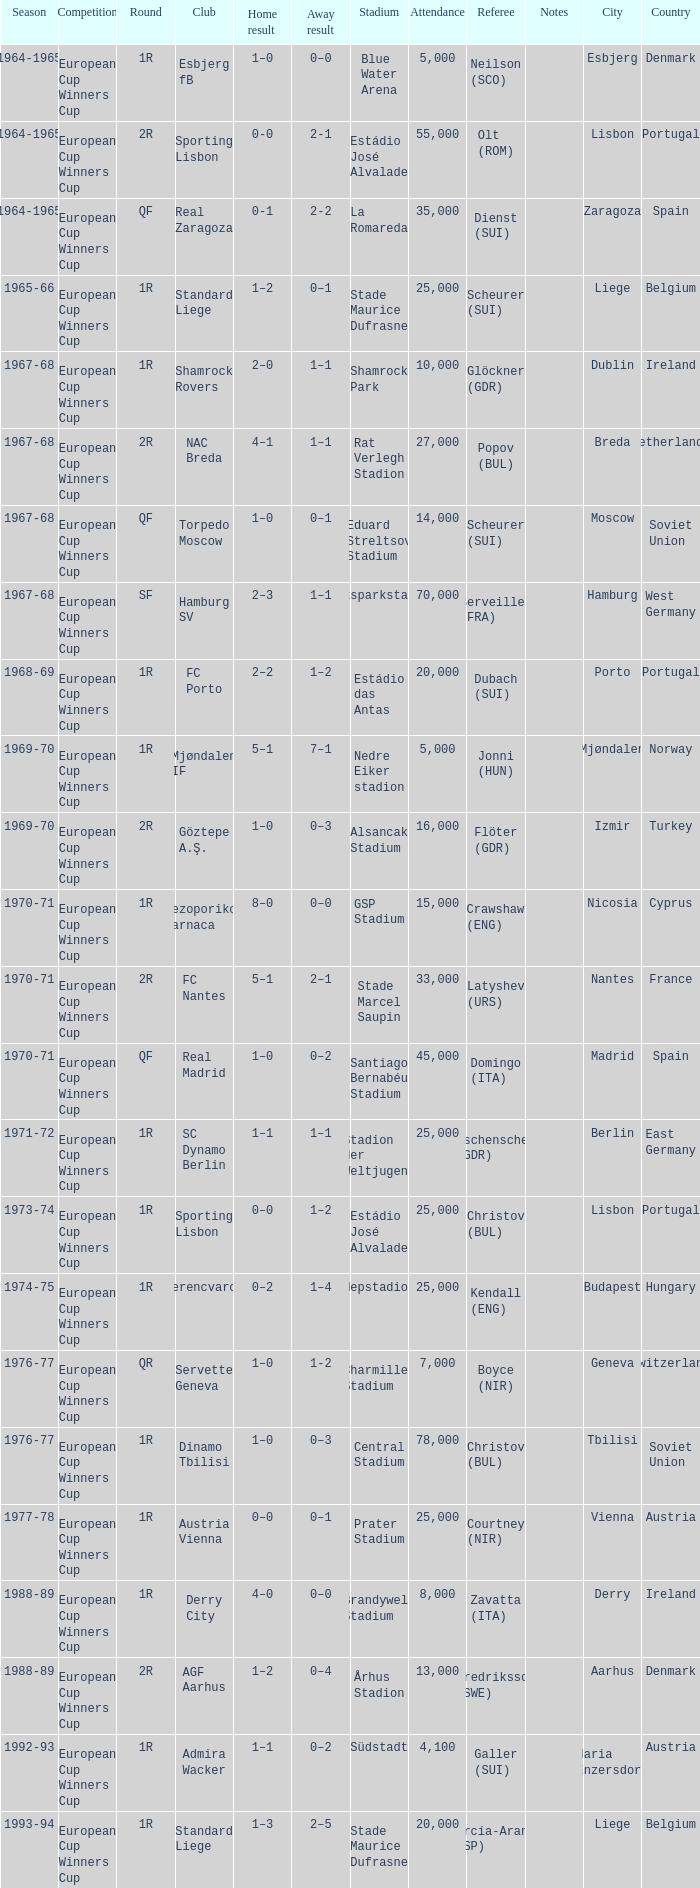Away result of 0–3, and a Season of 1969-70 is what competition? European Cup Winners Cup. 